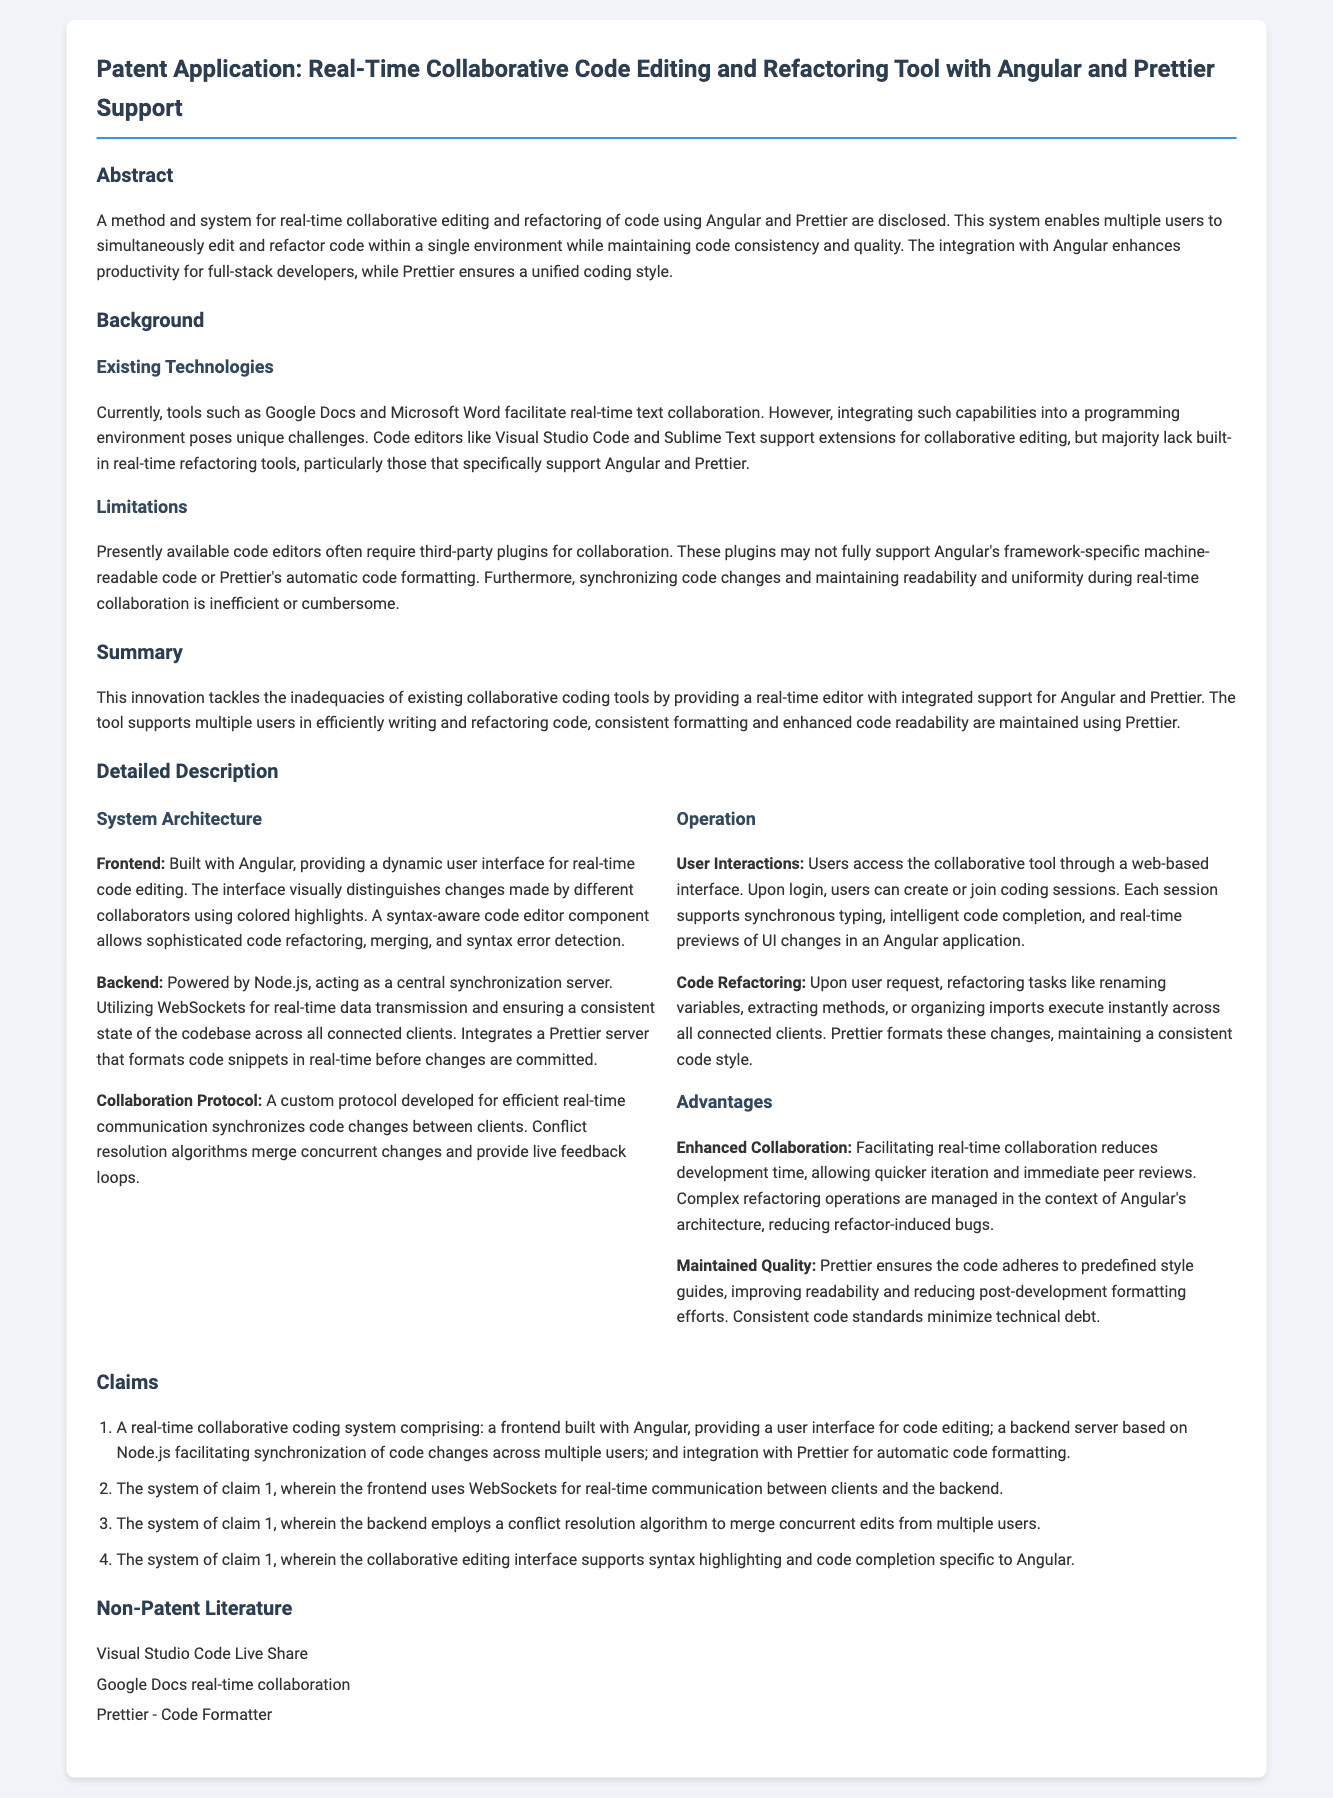What is the primary technology used for the frontend? The document states that the frontend is built with Angular, which provides the user interface for code editing.
Answer: Angular Which server technology supports the backend? The backend is powered by Node.js, as mentioned in the detailed description of the system architecture.
Answer: Node.js What system does the collaborative tool integrate for automatic code formatting? The document specifically mentions integration with Prettier for automatic code formatting in the collaborative coding system.
Answer: Prettier How many claims are presented in the claims section? The claims section contains four claims as detailed in the document.
Answer: Four What is one of the advantages of this collaborative coding tool? The document highlights enhanced collaboration, which reduces development time and allows quicker iteration and immediate peer reviews.
Answer: Enhanced Collaboration What type of communication does the frontend use for real-time interactions? The frontend uses WebSockets for real-time communication between clients and the backend, as noted in the claims.
Answer: WebSockets What does Prettier ensure during the code refactoring process? Prettier ensures that the code adheres to predefined style guides, as mentioned under the operation advantages of the tool.
Answer: Consistent code style What are the limitations of existing coding editors mentioned? Existing tool limitations are discussed in terms of requiring third-party plugins that may not support Angular's framework-specific code or Prettier's formatting.
Answer: Third-party plugins 